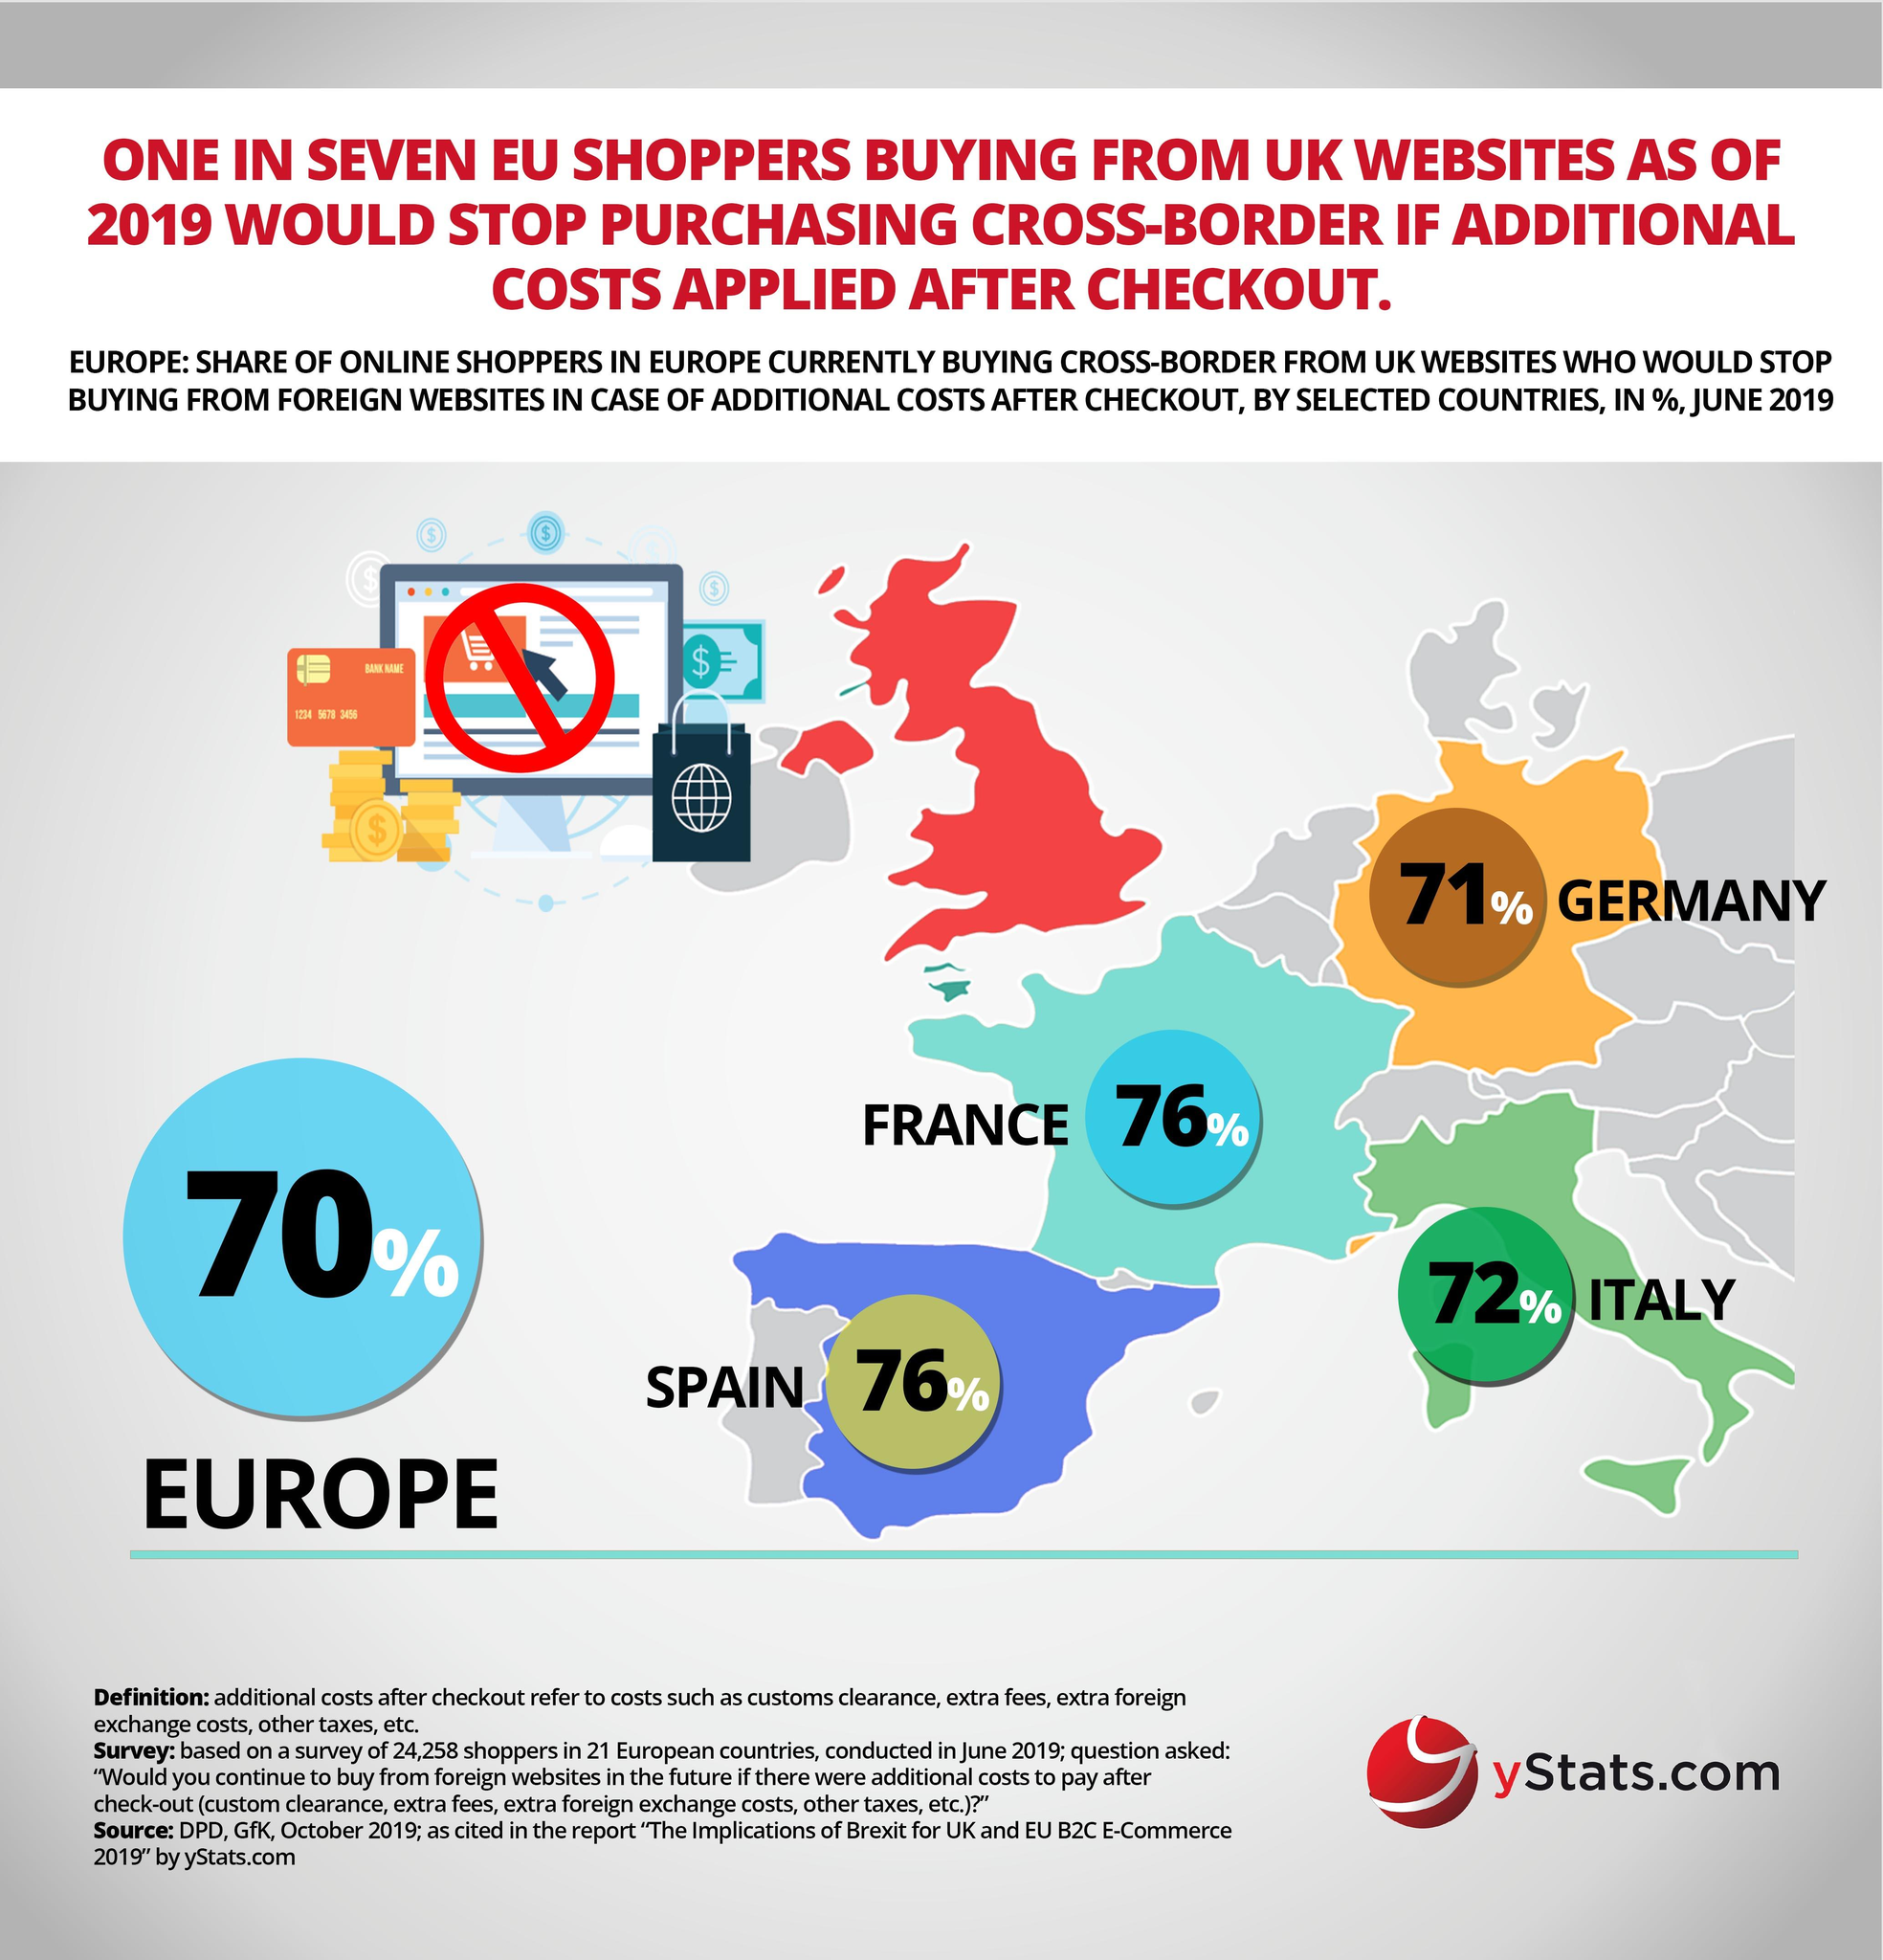Indicate a few pertinent items in this graphic. According to a survey, 71% of shoppers from Germany have stated that they would stop purchasing from UK websites if additional charges are applied. If additional charges are applied to shopping on UK websites, 76% of shoppers from Spain are likely to stop buying from these websites. According to the survey, 76% of French shoppers indicated that they would stop purchasing from UK websites if additional charges are applied. According to a recent survey, 72% of Italian shoppers have stated that they would stop purchasing from UK websites if additional charges are applied. 